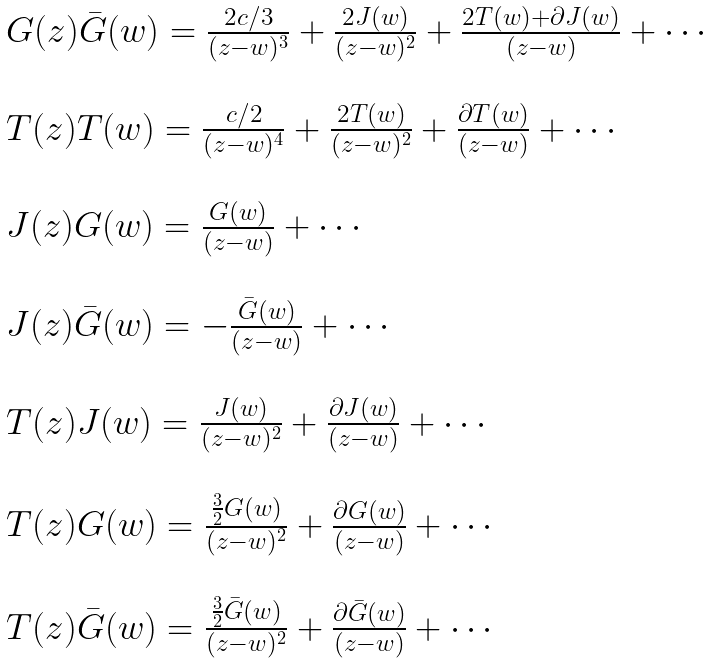Convert formula to latex. <formula><loc_0><loc_0><loc_500><loc_500>\begin{array} { l } { { G ( z ) \bar { G } ( w ) = \frac { 2 c / 3 } { ( z - w ) ^ { 3 } } + \frac { 2 J ( w ) } { ( z - w ) ^ { 2 } } + \frac { 2 T ( w ) + \partial J ( w ) } { ( z - w ) } + \cdots } } \\ { \ } \\ { { T ( z ) T ( w ) = \frac { c / 2 } { ( z - w ) ^ { 4 } } + \frac { 2 T ( w ) } { ( z - w ) ^ { 2 } } + \frac { \partial T ( w ) } { ( z - w ) } + \cdots } } \\ { \ } \\ { { J ( z ) G ( w ) = \frac { G ( w ) } { ( z - w ) } + \cdots } } \\ { \ } \\ { { J ( z ) \bar { G } ( w ) = - \frac { \bar { G } ( w ) } { ( z - w ) } + \cdots } } \\ { \ } \\ { { T ( z ) J ( w ) = \frac { J ( w ) } { ( z - w ) ^ { 2 } } + \frac { \partial J ( w ) } { ( z - w ) } + \cdots } } \\ { \ } \\ { { T ( z ) G ( w ) = \frac { \frac { 3 } { 2 } G ( w ) } { ( z - w ) ^ { 2 } } + \frac { \partial G ( w ) } { ( z - w ) } + \cdots } } \\ { \ } \\ { { T ( z ) \bar { G } ( w ) = \frac { \frac { 3 } { 2 } \bar { G } ( w ) } { ( z - w ) ^ { 2 } } + \frac { \partial \bar { G } ( w ) } { ( z - w ) } + \cdots } } \end{array}</formula> 